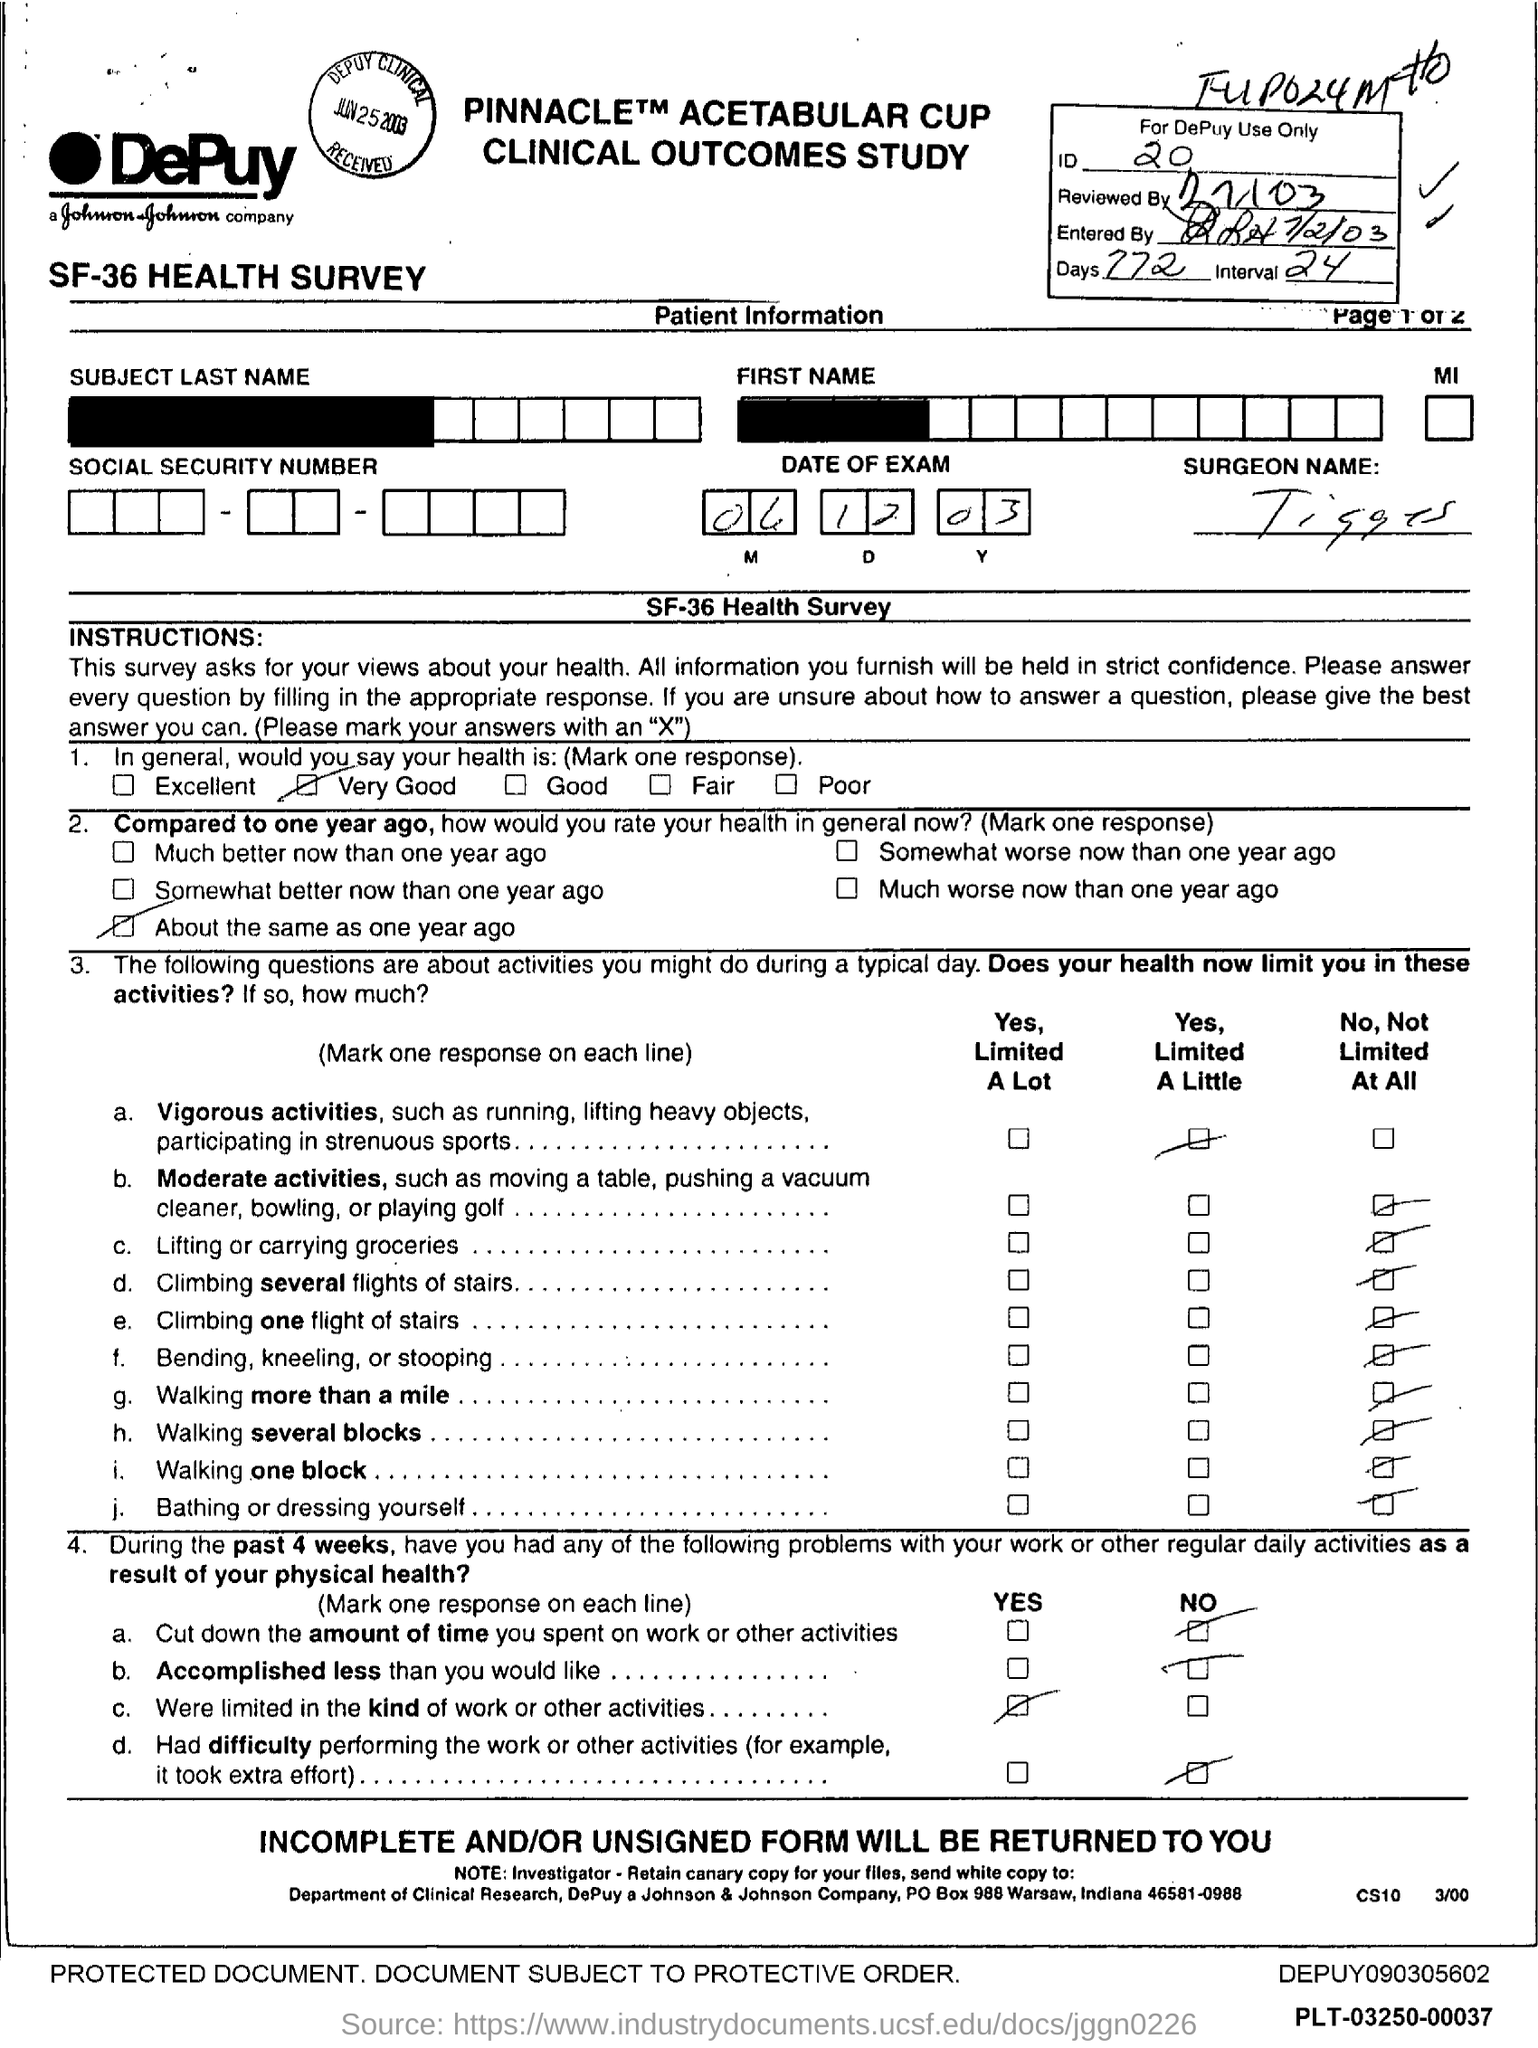Draw attention to some important aspects in this diagram. Seventy-seven days have elapsed. The Interval is a range of 24 hours starting from the current time. 